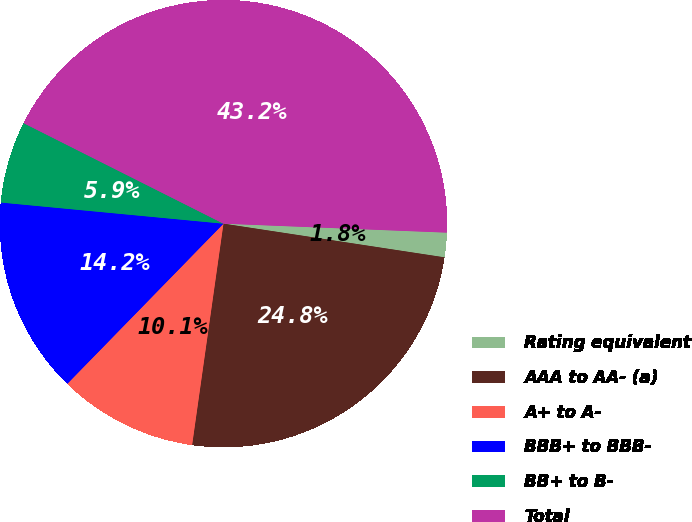<chart> <loc_0><loc_0><loc_500><loc_500><pie_chart><fcel>Rating equivalent<fcel>AAA to AA- (a)<fcel>A+ to A-<fcel>BBB+ to BBB-<fcel>BB+ to B-<fcel>Total<nl><fcel>1.77%<fcel>24.83%<fcel>10.06%<fcel>14.21%<fcel>5.91%<fcel>43.22%<nl></chart> 